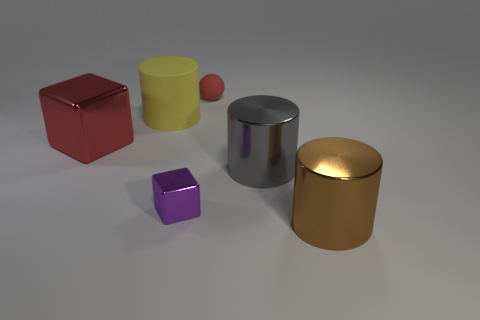There is a big block that is the same color as the small sphere; what is its material?
Your answer should be very brief. Metal. What is the shape of the matte object to the right of the rubber object to the left of the tiny object in front of the small red thing?
Provide a succinct answer. Sphere. What number of blocks are made of the same material as the yellow cylinder?
Your response must be concise. 0. There is a big metallic cylinder behind the small purple thing; what number of large red metal cubes are to the left of it?
Give a very brief answer. 1. How many tiny cylinders are there?
Make the answer very short. 0. Are the large gray thing and the cylinder that is left of the gray metallic thing made of the same material?
Offer a very short reply. No. There is a cylinder that is on the left side of the tiny red matte thing; does it have the same color as the matte sphere?
Give a very brief answer. No. There is a cylinder that is on the right side of the red matte ball and behind the purple shiny cube; what is its material?
Provide a short and direct response. Metal. The brown metal cylinder has what size?
Ensure brevity in your answer.  Large. There is a large matte object; is it the same color as the small object on the left side of the ball?
Your answer should be compact. No. 